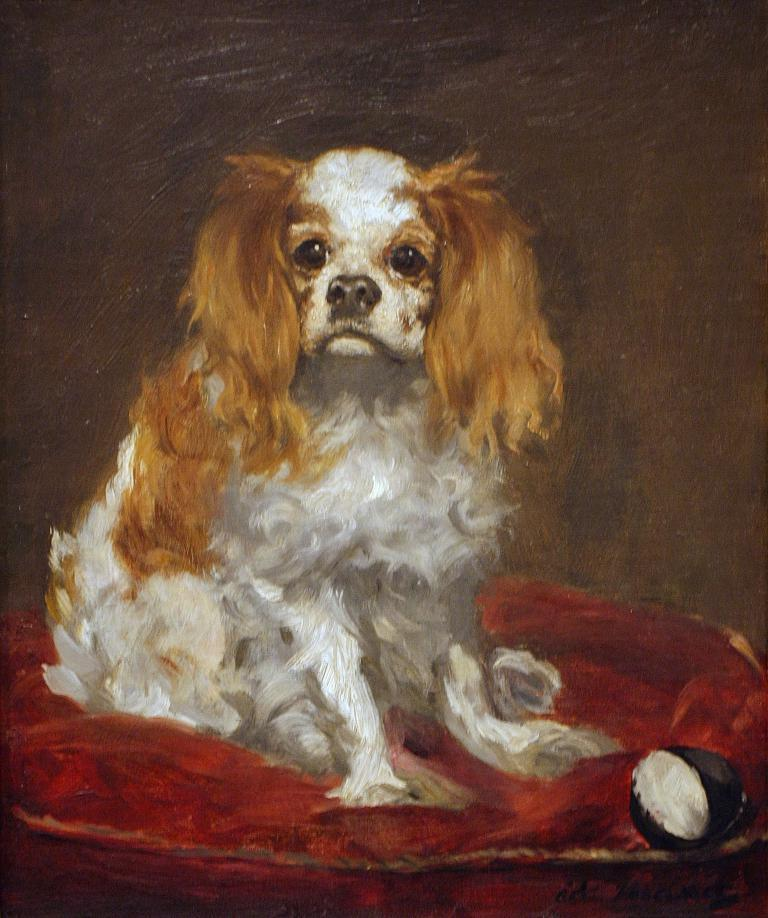What is the main subject of the image? There is a painting in the image. What is depicted in the painting? The painting depicts a dog. Can you describe the appearance of the dog in the painting? The dog is in brown and white color. What day of the week is depicted in the painting? The painting does not depict a day of the week; it features a dog. Are there any police officers present in the painting? There are no police officers depicted in the painting; it features a dog. 